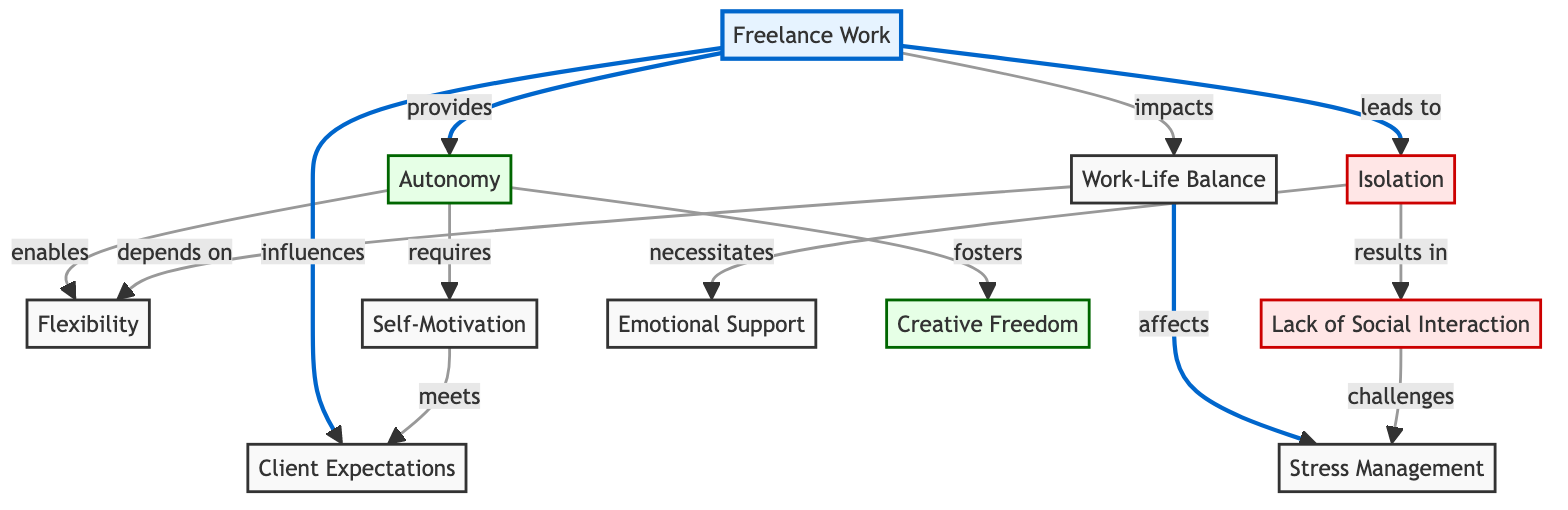What are the two main psychological aspects of freelance work depicted in the diagram? The two main psychological aspects are Autonomy and Isolation. They are highlighted as the key components that freelance work provides and leads to.
Answer: Autonomy, Isolation How many nodes are labeled as having a negative impact? There are three nodes in the diagram that are identified with a negative impact: Isolation, Lack of Social Interaction, and Stress Management. Thus, the count of negative nodes is three.
Answer: 3 What does Autonomy enable according to the diagram? According to the diagram, Autonomy enables Flexibility. This is shown by the direct link from Autonomy to Flexibility.
Answer: Flexibility What does Isolation necessitate? Isolation necessitates Emotional Support, as indicated by the direct relationship between the Isolation node and Emotional Support in the diagram.
Answer: Emotional Support Which node affects Work-Life Balance? The node that affects Work-Life Balance is Freelance Work, as mentioned in the diagram with a direct link impacting Work-Life Balance.
Answer: Freelance Work How does Stress Management connect to Work-Life Balance in the diagram? Stress Management connects to Work-Life Balance indirectly; it depends on the impact of Autonomy on Work-Life Balance. Thus, while it's not a direct link, it is influenced by the overall elements within the diagram affecting Work-Life Balance.
Answer: Indirectly Which positive aspect does Creative Freedom foster in the context of freelance work? Creative Freedom fosters Autonomy, as indicated by the connection shown in the diagram linking Creative Freedom to Autonomy within the freelance work context.
Answer: Autonomy What influences Client Expectations in the diagram? Client Expectations are influenced by Freelance Work, as shown by the direct link from the Freelance Work node to the Client Expectations node in the diagram.
Answer: Freelance Work What challenges arise due to Lack of Social Interaction? Lack of Social Interaction challenges Stress Management, reflecting how isolation impacts the ability to manage stress effectively within freelance work.
Answer: Stress Management 